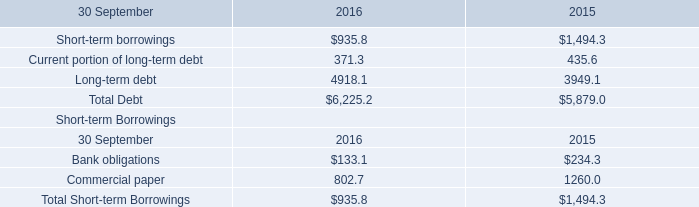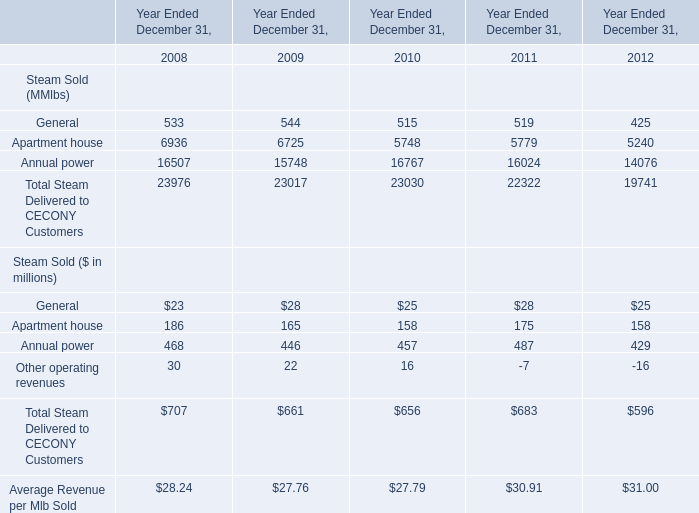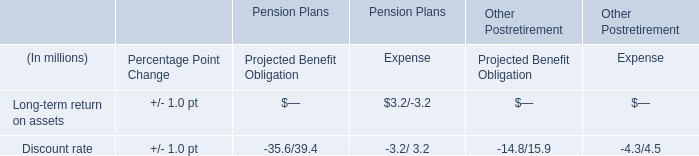considering the years 2014-2016 , what was the average cash paid for interest? 
Computations: ((132.4 + (121.1 + 97.5)) / 3)
Answer: 117.0. 